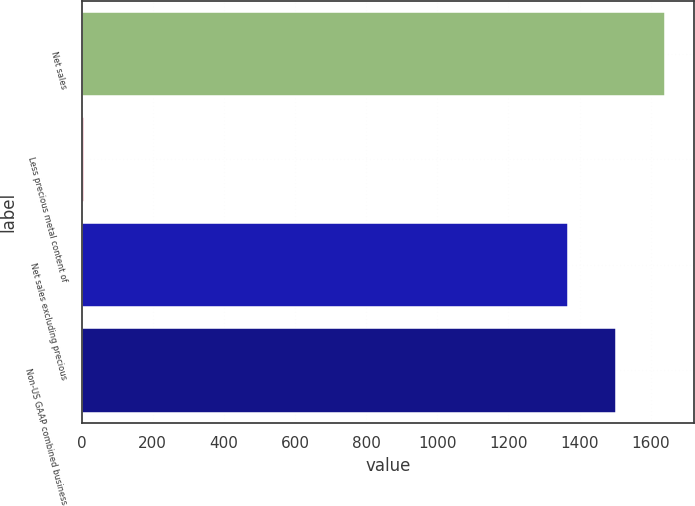Convert chart to OTSL. <chart><loc_0><loc_0><loc_500><loc_500><bar_chart><fcel>Net sales<fcel>Less precious metal content of<fcel>Net sales excluding precious<fcel>Non-US GAAP combined business<nl><fcel>1640.16<fcel>5.7<fcel>1366.8<fcel>1503.48<nl></chart> 